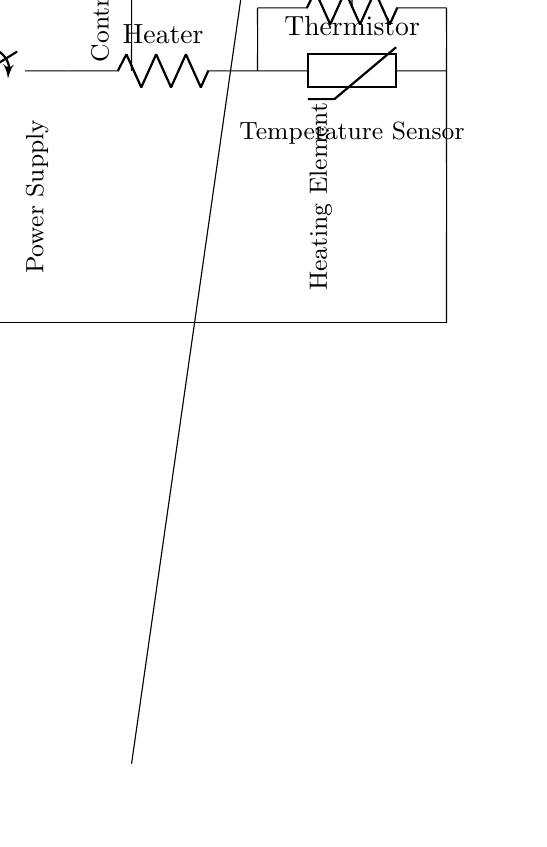What is the main function of the thermistor in this circuit? The thermistor is used as a temperature sensor; it provides feedback on the temperature to regulate the heating element.
Answer: Temperature sensor What is the role of the control circuit? The control circuit processes the input from the thermistor and adjusts the heating element based on the desired temperature.
Answer: Adjusting temperature What happens when the switch is closed? When the switch is closed, it completes the circuit allowing current to flow from the battery to the heating element, turning it on.
Answer: Current flows What types of components are used in this circuit? The circuit includes a battery, switch, resistor, thermistor, and an operational amplifier.
Answer: Battery, switch, resistor, thermistor, op amp How is the heating element connected in this circuit? The heating element is connected in series with the thermistor and the switch, allowing for the control of its operation based on temperature feedback.
Answer: In series What is the connection type between the power supply and the switch? The connection type is series, as the power supply directly connects to the switch to control the current flow.
Answer: Series What is the significance of the operational amplifier in this circuit? The operational amplifier amplifies the signal from the thermistor, allowing for precise control of the heating element based on temperature changes.
Answer: Signal amplification 